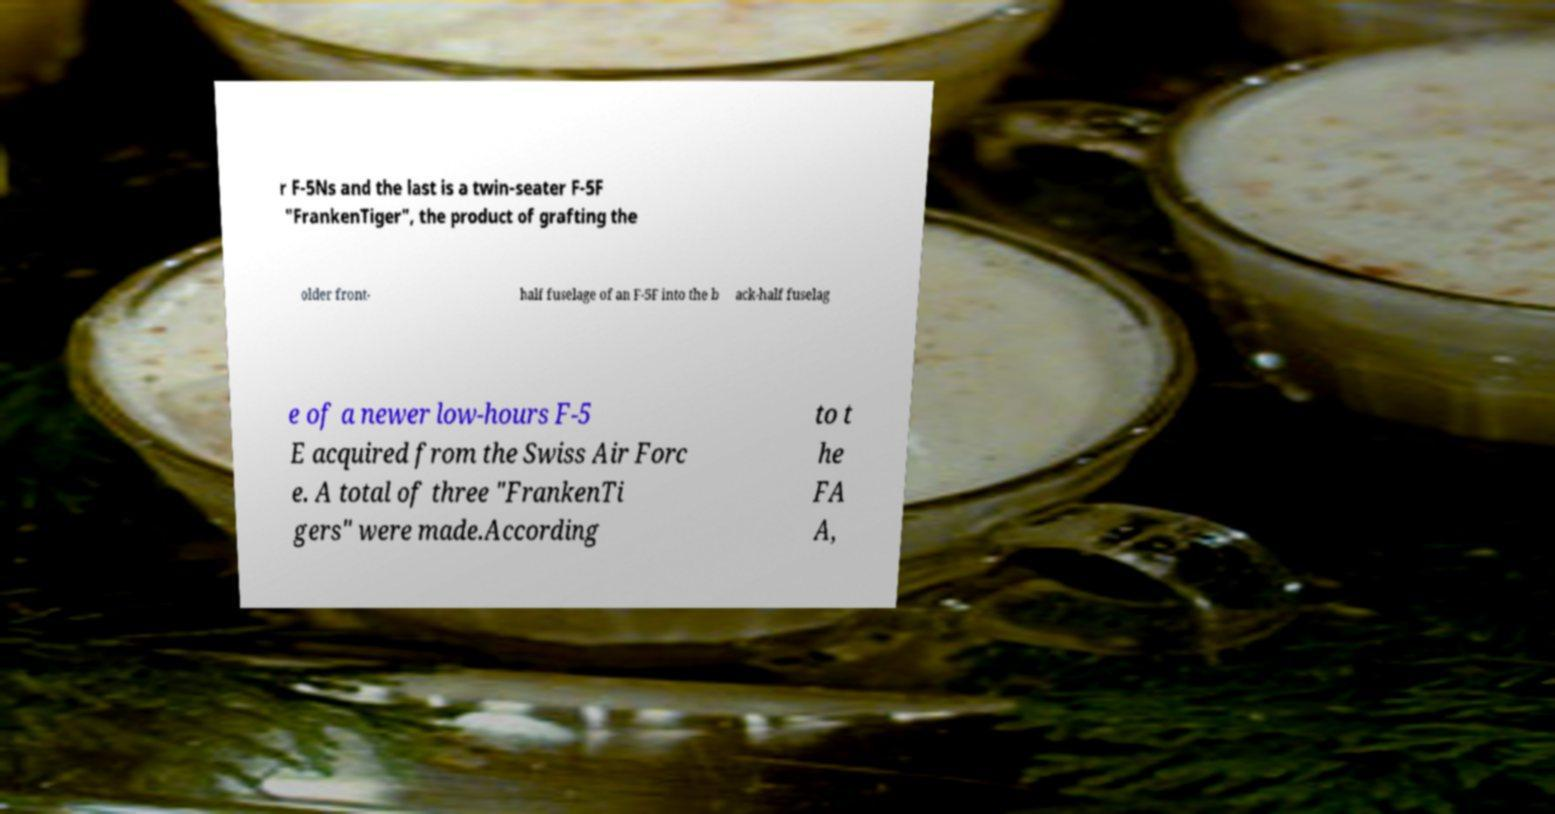What messages or text are displayed in this image? I need them in a readable, typed format. r F-5Ns and the last is a twin-seater F-5F "FrankenTiger", the product of grafting the older front- half fuselage of an F-5F into the b ack-half fuselag e of a newer low-hours F-5 E acquired from the Swiss Air Forc e. A total of three "FrankenTi gers" were made.According to t he FA A, 